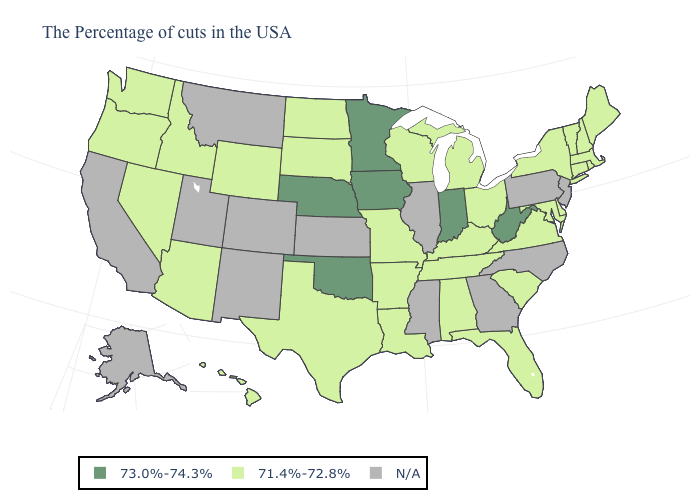Which states have the lowest value in the USA?
Keep it brief. Maine, Massachusetts, Rhode Island, New Hampshire, Vermont, Connecticut, New York, Delaware, Maryland, Virginia, South Carolina, Ohio, Florida, Michigan, Kentucky, Alabama, Tennessee, Wisconsin, Louisiana, Missouri, Arkansas, Texas, South Dakota, North Dakota, Wyoming, Arizona, Idaho, Nevada, Washington, Oregon, Hawaii. What is the value of Missouri?
Short answer required. 71.4%-72.8%. Name the states that have a value in the range N/A?
Answer briefly. New Jersey, Pennsylvania, North Carolina, Georgia, Illinois, Mississippi, Kansas, Colorado, New Mexico, Utah, Montana, California, Alaska. Among the states that border Iowa , which have the lowest value?
Keep it brief. Wisconsin, Missouri, South Dakota. Name the states that have a value in the range N/A?
Quick response, please. New Jersey, Pennsylvania, North Carolina, Georgia, Illinois, Mississippi, Kansas, Colorado, New Mexico, Utah, Montana, California, Alaska. What is the value of Connecticut?
Write a very short answer. 71.4%-72.8%. Does West Virginia have the lowest value in the USA?
Concise answer only. No. Does Virginia have the lowest value in the USA?
Give a very brief answer. Yes. Is the legend a continuous bar?
Write a very short answer. No. What is the value of North Carolina?
Give a very brief answer. N/A. What is the value of Washington?
Answer briefly. 71.4%-72.8%. Which states have the lowest value in the West?
Answer briefly. Wyoming, Arizona, Idaho, Nevada, Washington, Oregon, Hawaii. 